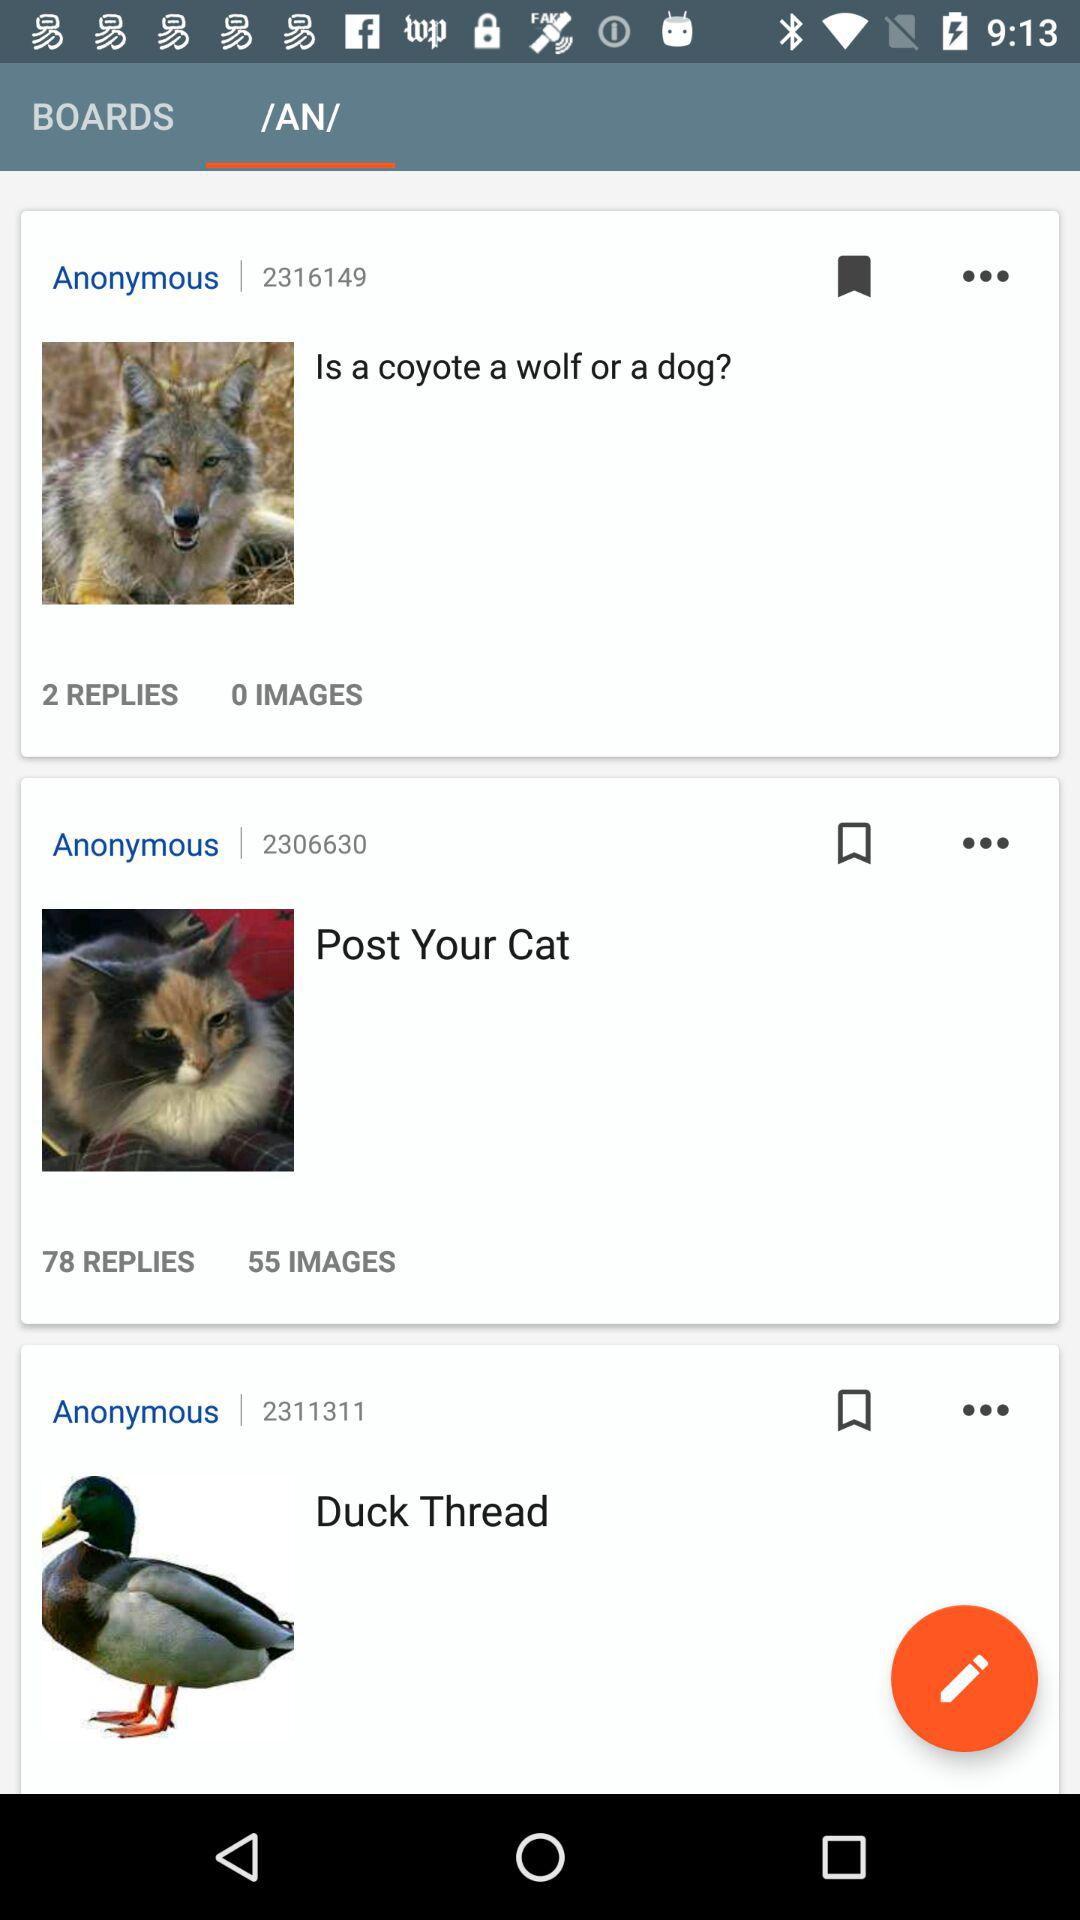How many images are in the "Post Your Cat"? There are 55 images in the "Post Your Cat". 